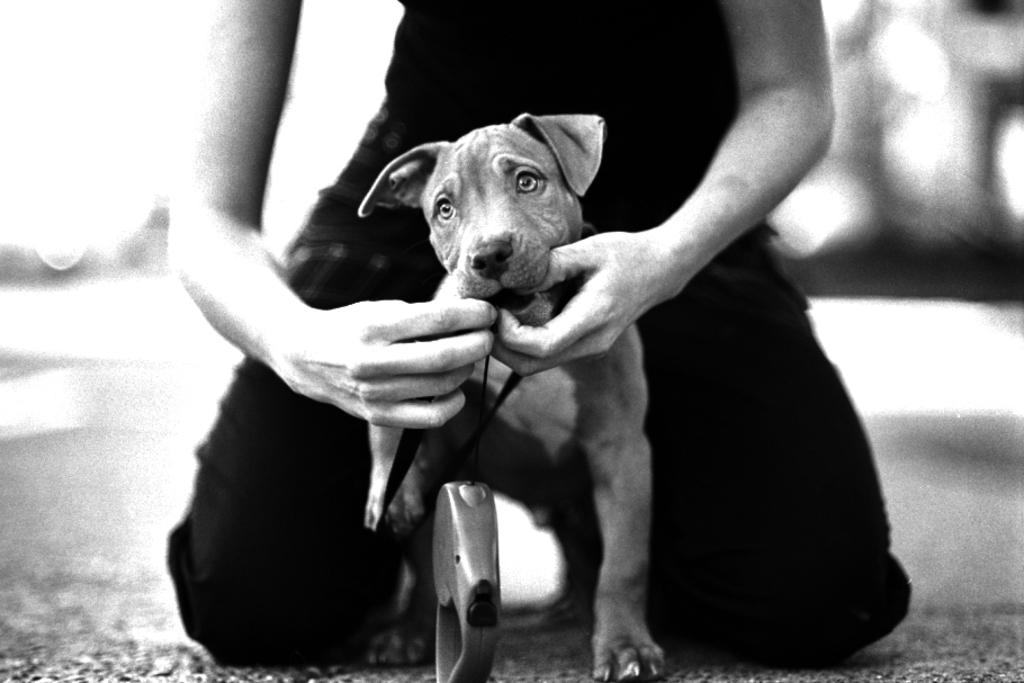What is the color scheme of the image? The picture is in black and white. Can you describe the main subject of the image? There is a person in the image. What is the person doing in the image? The person is holding a dog. What type of juice is the person drinking in the image? There is no juice present in the image; it is in black and white and features a person holding a dog. 